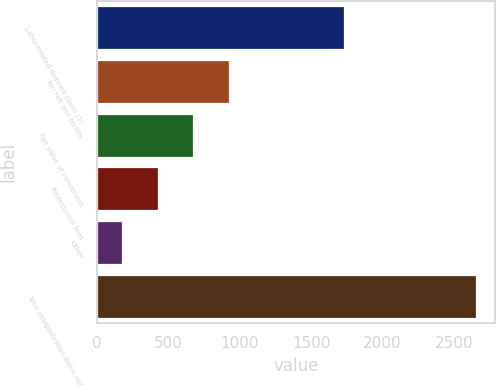Convert chart. <chart><loc_0><loc_0><loc_500><loc_500><bar_chart><fcel>Labor-related deemed claim (1)<fcel>Aircraft and facility<fcel>Fair value of conversion<fcel>Professional fees<fcel>Other<fcel>Total reorganization items net<nl><fcel>1733<fcel>922.5<fcel>675<fcel>427.5<fcel>180<fcel>2655<nl></chart> 